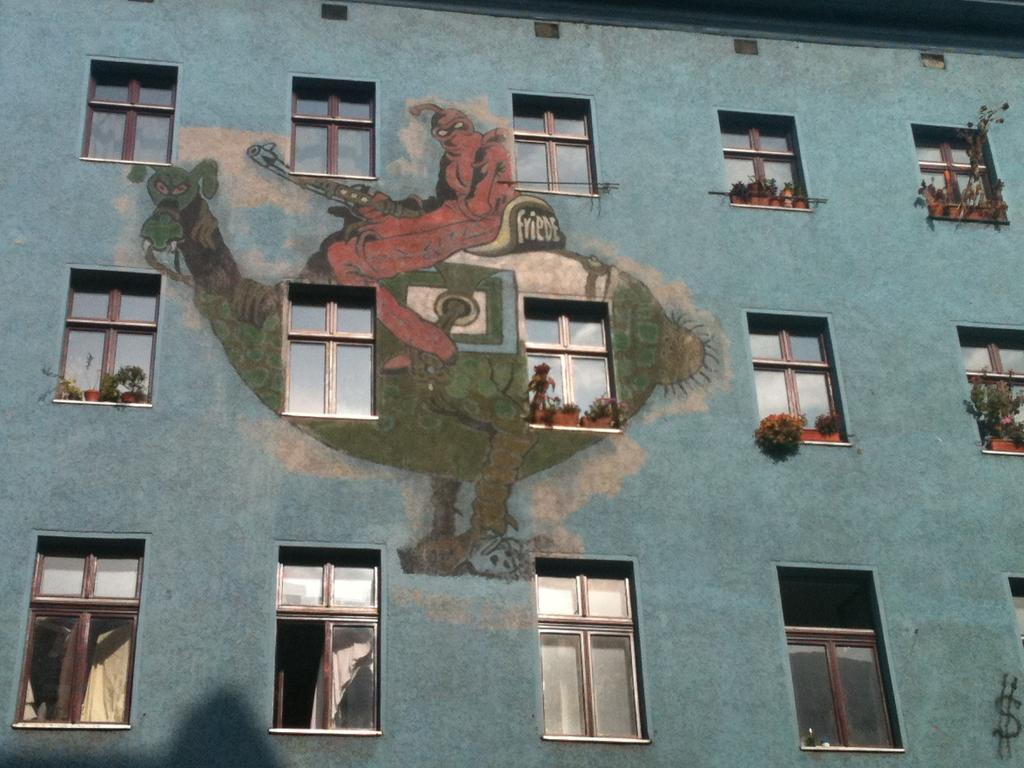What is the color of the building in the image? The building in the image is blue. What type of windows does the building have? The building has glass windows. What can be seen on the windows of the building? Plants are kept on the windows of the building. How many planes are parked on the roof of the building in the image? There are no planes visible on the roof of the building in the image. What type of card is being used to water the plants on the windows of the building? There is no card present in the image; the plants are not being watered with a card. 